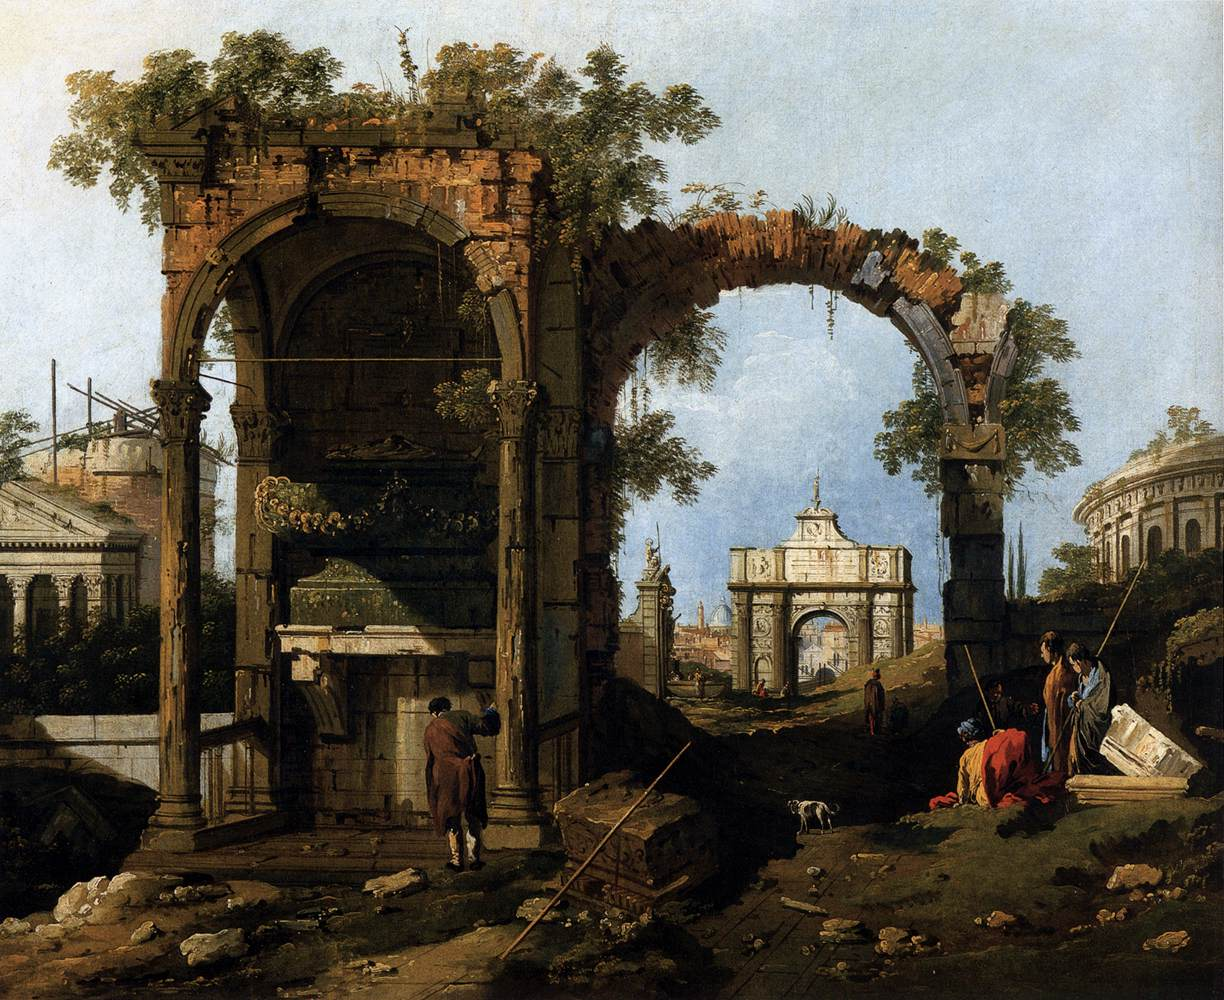Imagine stepping into this scene. What sounds might you hear? If you were to step into this scene, you might hear the soft rustling of leaves as a gentle breeze moves through the foliage. The distant chatter of the figures animating the foreground could reach your ears, interspersed with the occasional call of birds. The faint sound of footsteps on the stone and earth path, and perhaps the distant murmur of a city beyond the ruins, would add to the tapestry of sounds. It is a blend of nature and human presence in a timeless landscape. 